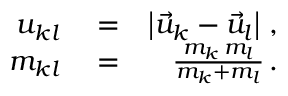Convert formula to latex. <formula><loc_0><loc_0><loc_500><loc_500>\begin{array} { r l r } { u _ { k l } } & = } & { \left | \vec { u } _ { k } - \vec { u } _ { l } \right | \, , } \\ { m _ { k l } } & = } & { \frac { m _ { k } \, m _ { l } } { m _ { k } + m _ { l } } \, . } \end{array}</formula> 